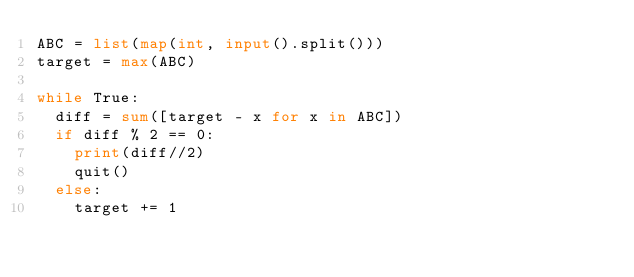<code> <loc_0><loc_0><loc_500><loc_500><_Python_>ABC = list(map(int, input().split()))
target = max(ABC)

while True:
  diff = sum([target - x for x in ABC])
  if diff % 2 == 0:
    print(diff//2)
    quit()
  else:
    target += 1</code> 